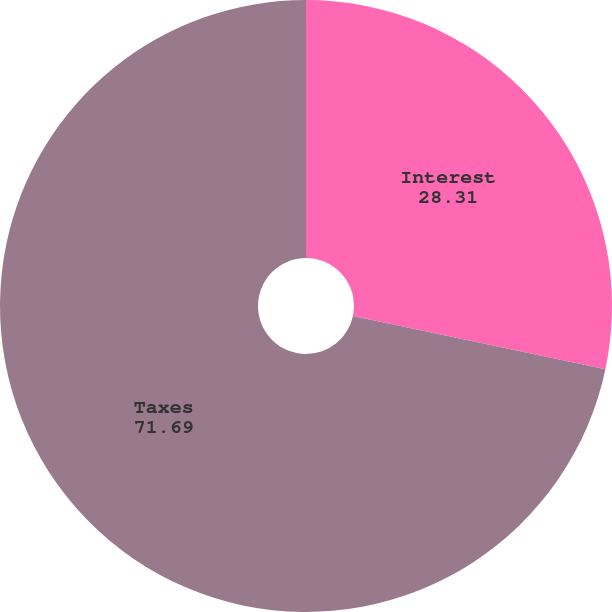<chart> <loc_0><loc_0><loc_500><loc_500><pie_chart><fcel>Interest<fcel>Taxes<nl><fcel>28.31%<fcel>71.69%<nl></chart> 